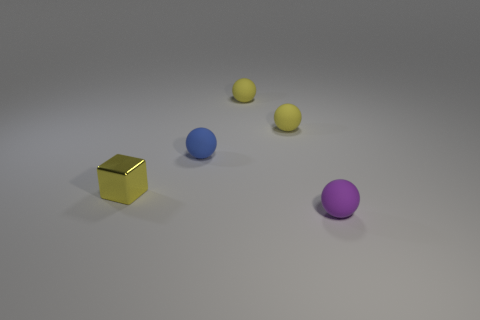Subtract all small blue balls. How many balls are left? 3 Subtract all blue balls. How many balls are left? 3 Add 5 small purple metal cubes. How many objects exist? 10 Add 5 blue spheres. How many blue spheres are left? 6 Add 4 blue spheres. How many blue spheres exist? 5 Subtract 1 blue balls. How many objects are left? 4 Subtract all cubes. How many objects are left? 4 Subtract 1 cubes. How many cubes are left? 0 Subtract all blue cubes. Subtract all purple balls. How many cubes are left? 1 Subtract all gray cubes. How many green balls are left? 0 